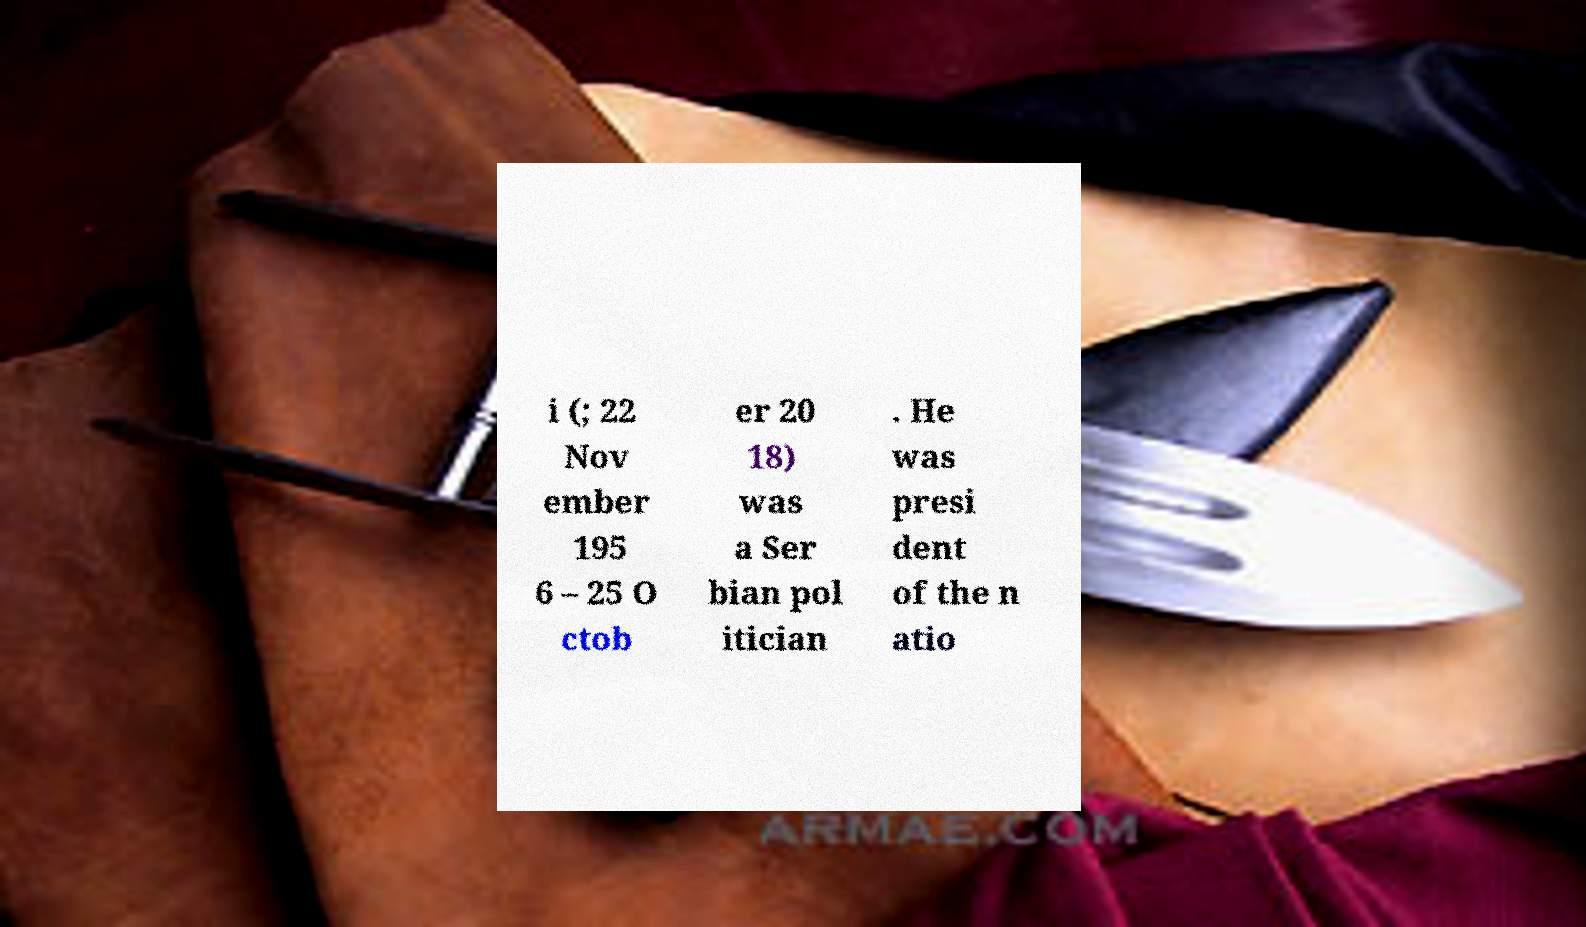I need the written content from this picture converted into text. Can you do that? i (; 22 Nov ember 195 6 – 25 O ctob er 20 18) was a Ser bian pol itician . He was presi dent of the n atio 